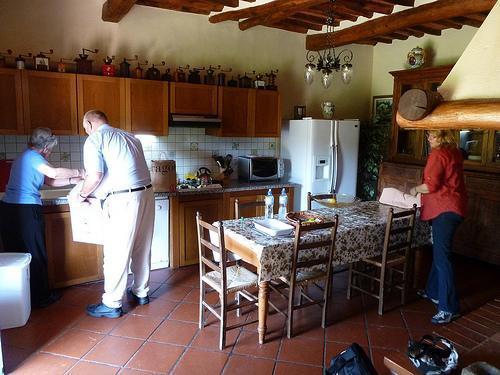How many people in picture?
Give a very brief answer. 3. 